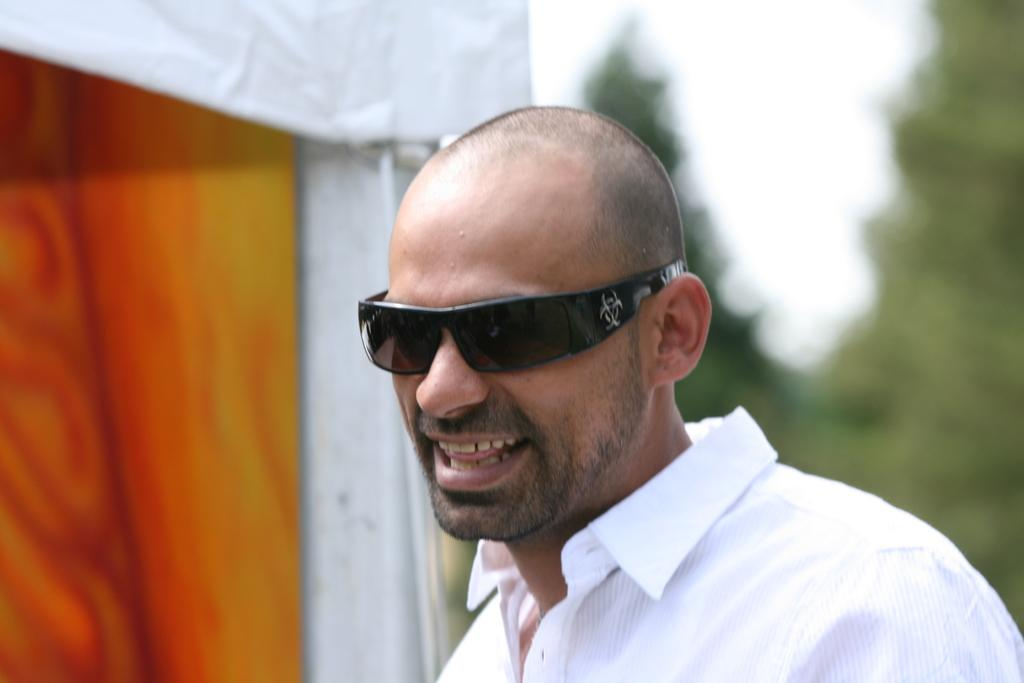What is the main subject in the foreground of the image? There is a man in the foreground of the image. What is the man wearing? The man is wearing goggles. How is the man feeling in the image? The man is laughing in the image. What can be observed about the background of the image? The background of the man is blurred. Why is the man crying in the image? The man is not crying in the image; he is laughing. What type of plastic object can be seen in the man's hand in the image? There is no plastic object visible in the man's hand in the image. 